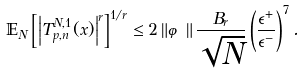<formula> <loc_0><loc_0><loc_500><loc_500>\mathbb { E } _ { N } \left [ \left | T _ { p , n } ^ { N , 1 } ( x ) \right | ^ { r } \right ] ^ { 1 / r } \leq 2 \left \| \varphi \right \| \frac { B _ { r } } { \sqrt { N } } \left ( \frac { \epsilon ^ { + } } { \epsilon ^ { - } } \right ) ^ { 7 } .</formula> 